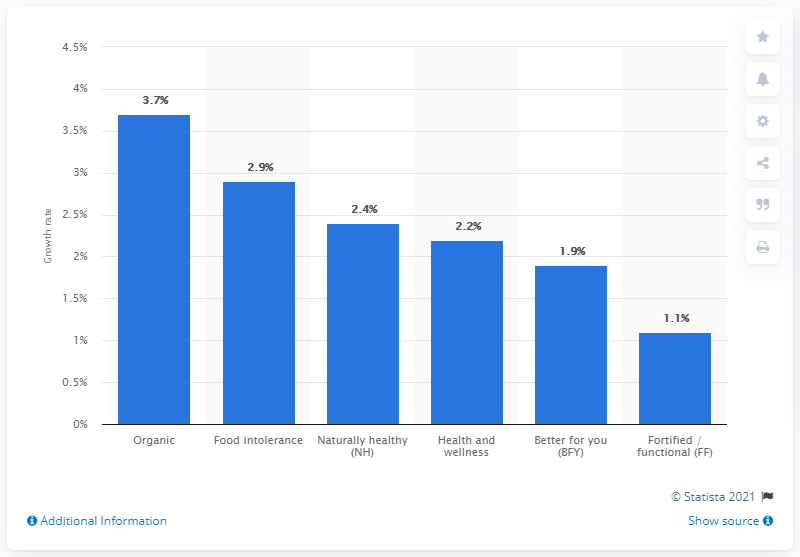Identify some key points in this picture. The growth rate of organic food and beverage in the five years under consideration was 3.7%. The growth rate of food intolerance products is 2.9%. 